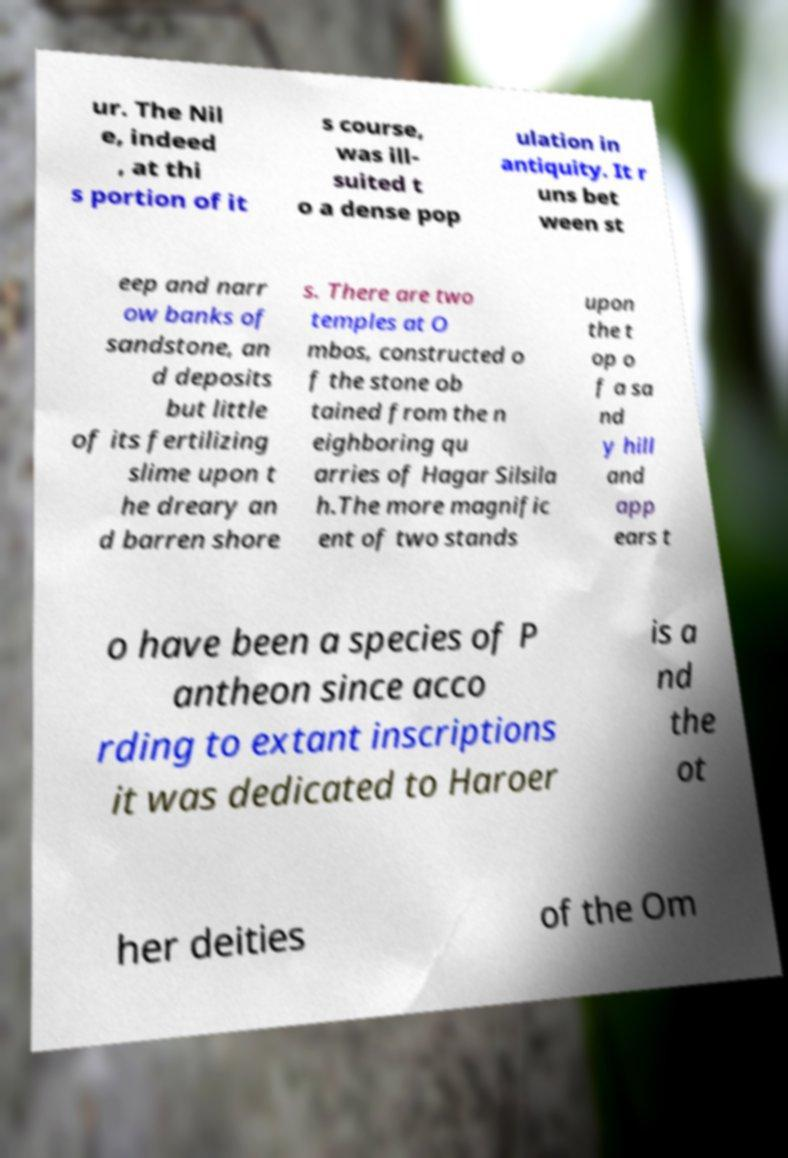There's text embedded in this image that I need extracted. Can you transcribe it verbatim? ur. The Nil e, indeed , at thi s portion of it s course, was ill- suited t o a dense pop ulation in antiquity. It r uns bet ween st eep and narr ow banks of sandstone, an d deposits but little of its fertilizing slime upon t he dreary an d barren shore s. There are two temples at O mbos, constructed o f the stone ob tained from the n eighboring qu arries of Hagar Silsila h.The more magnific ent of two stands upon the t op o f a sa nd y hill and app ears t o have been a species of P antheon since acco rding to extant inscriptions it was dedicated to Haroer is a nd the ot her deities of the Om 